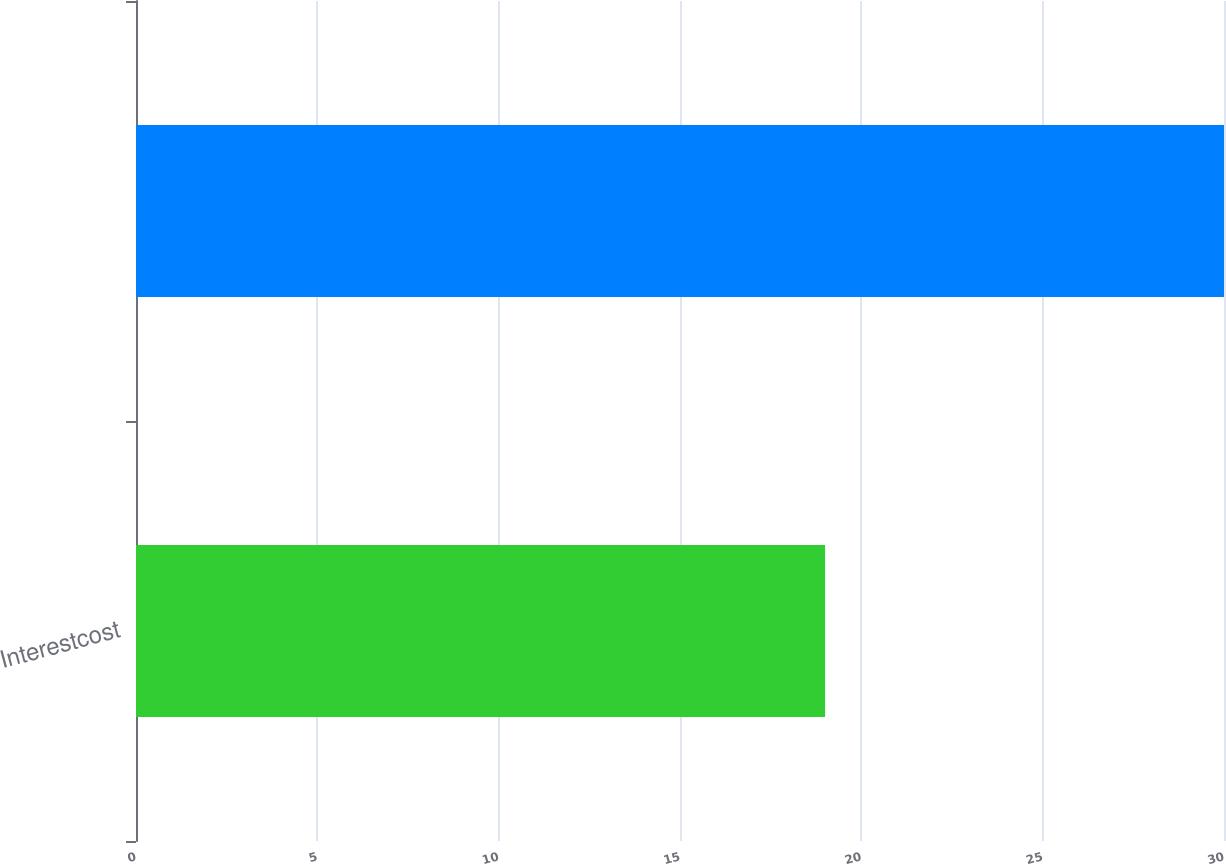Convert chart. <chart><loc_0><loc_0><loc_500><loc_500><bar_chart><fcel>Interestcost<fcel>Unnamed: 1<nl><fcel>19<fcel>30<nl></chart> 